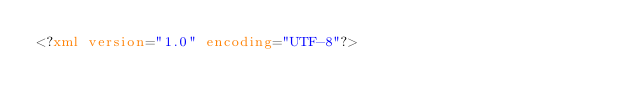Convert code to text. <code><loc_0><loc_0><loc_500><loc_500><_XML_><?xml version="1.0" encoding="UTF-8"?></code> 